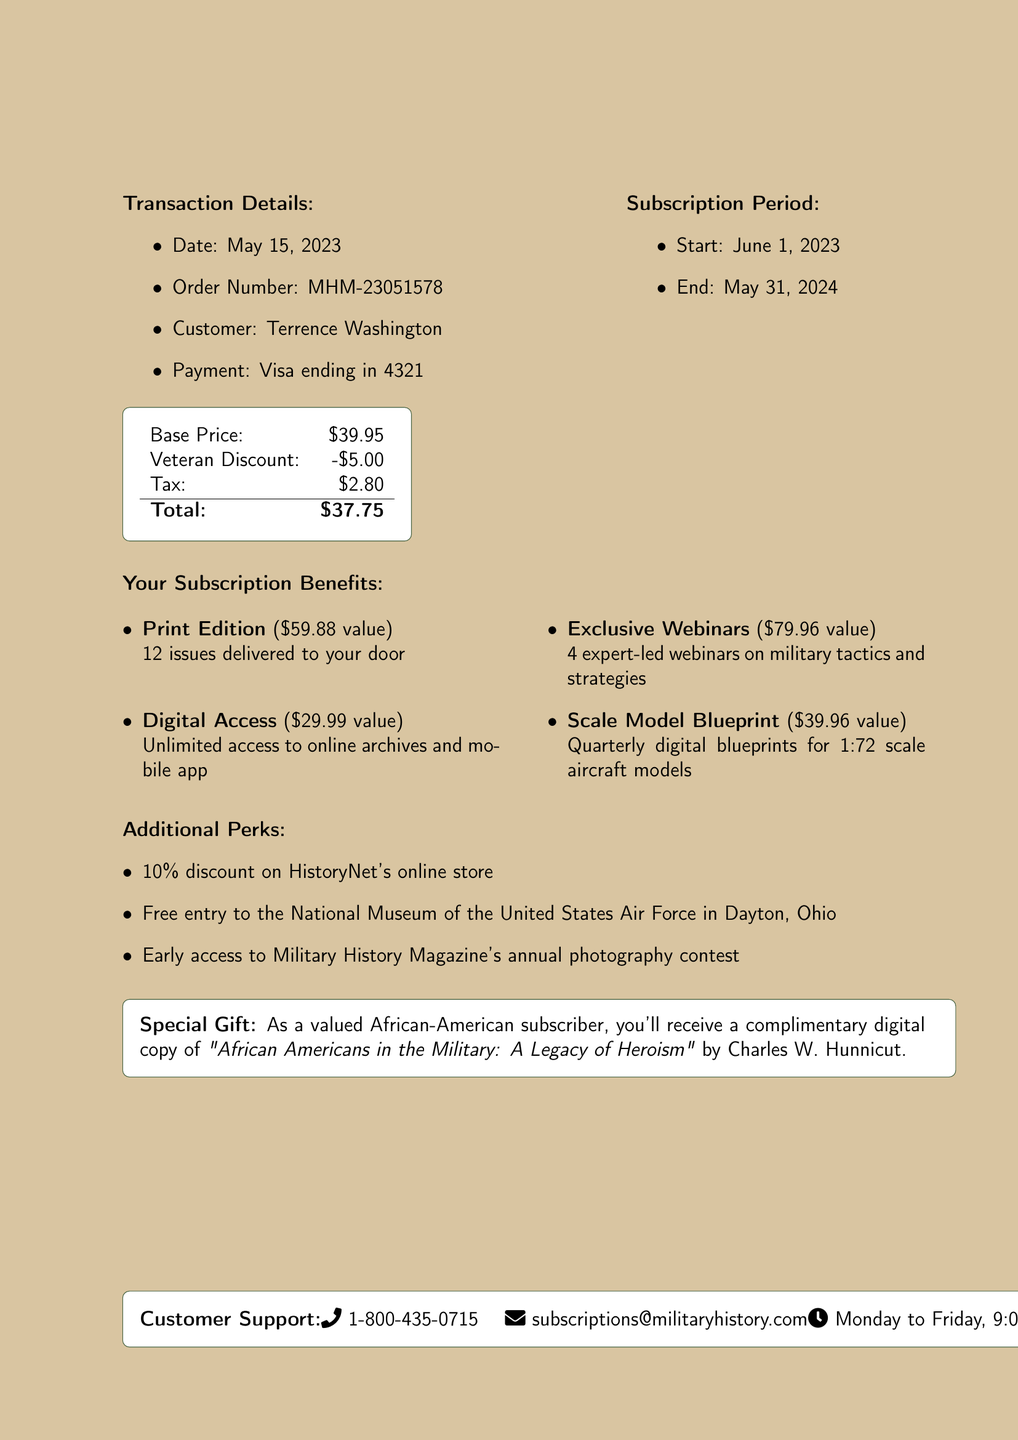what is the customer's name? The customer's name is listed in the transaction details section of the document.
Answer: Terrence Washington when does the subscription start? The start date of the subscription is specified in the subscription information section.
Answer: June 1, 2023 what is the order number? The order number can be found in the transaction details section of the document.
Answer: MHM-23051578 how much is the veteran discount? The document states the amount of the veteran discount in the pricing section.
Answer: $5.00 what is the total amount paid? The total amount paid is the final figure shown in the pricing section after applying discounts and tax.
Answer: $37.75 what are the additional perks of the subscription? The additional perks are listed in a specific section of the document, highlighting exclusive benefits.
Answer: 10% discount on HistoryNet's online store, Free entry to the National Museum of the United States Air Force in Dayton, Ohio, Early access to Military History Magazine's annual photography contest how many issues are delivered in the print edition? The document mentions the number of issues included in the print edition in the benefits section.
Answer: 12 issues what is the value of the Scale Model Blueprint benefit? The value of this specific benefit is clearly indicated in the benefits section of the document.
Answer: $39.96 who should be contacted for customer support? The customer support contact details are specified at the end of the document.
Answer: subscriptions@militaryhistory.com 